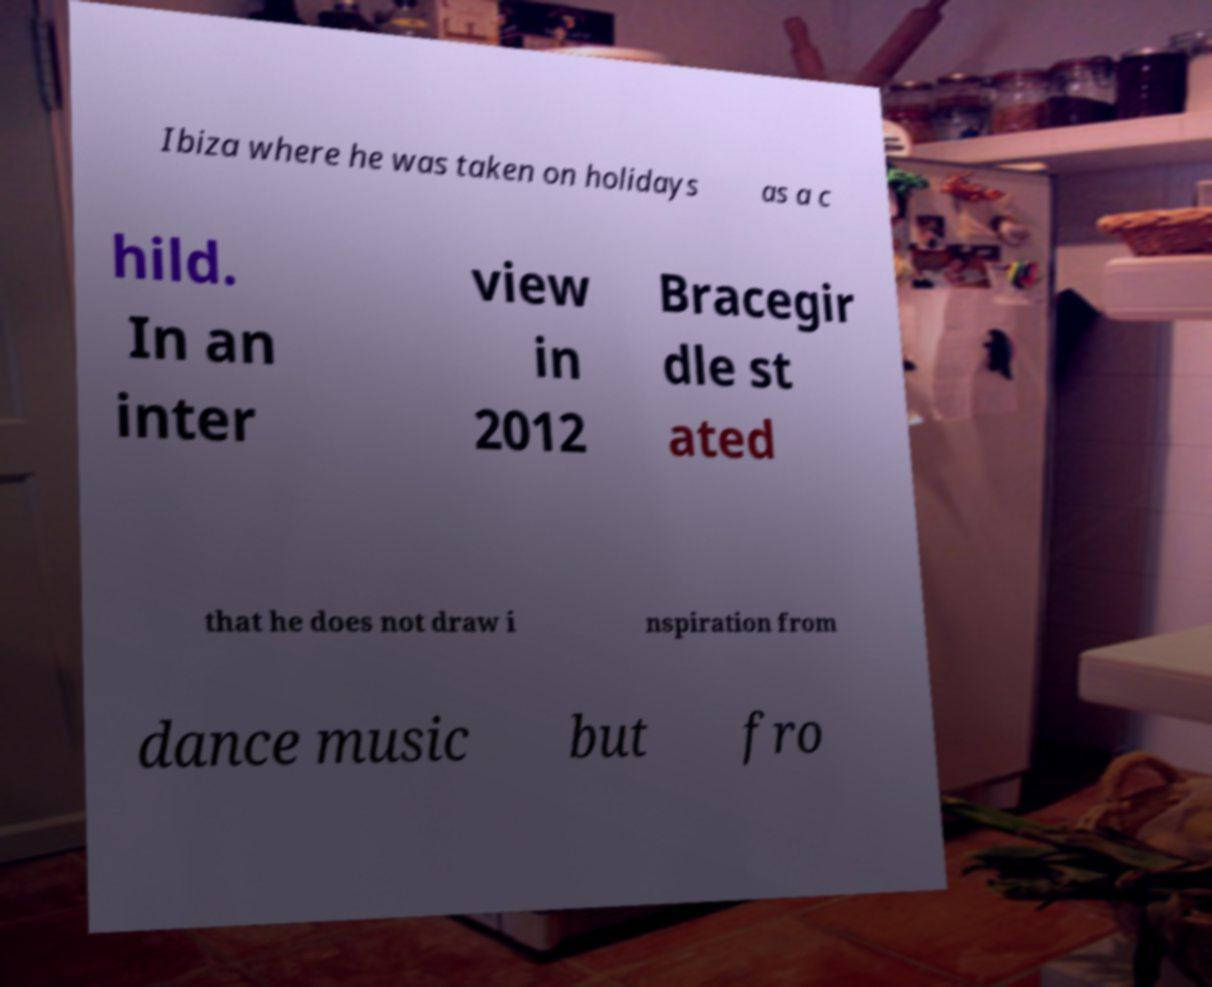Could you extract and type out the text from this image? Ibiza where he was taken on holidays as a c hild. In an inter view in 2012 Bracegir dle st ated that he does not draw i nspiration from dance music but fro 